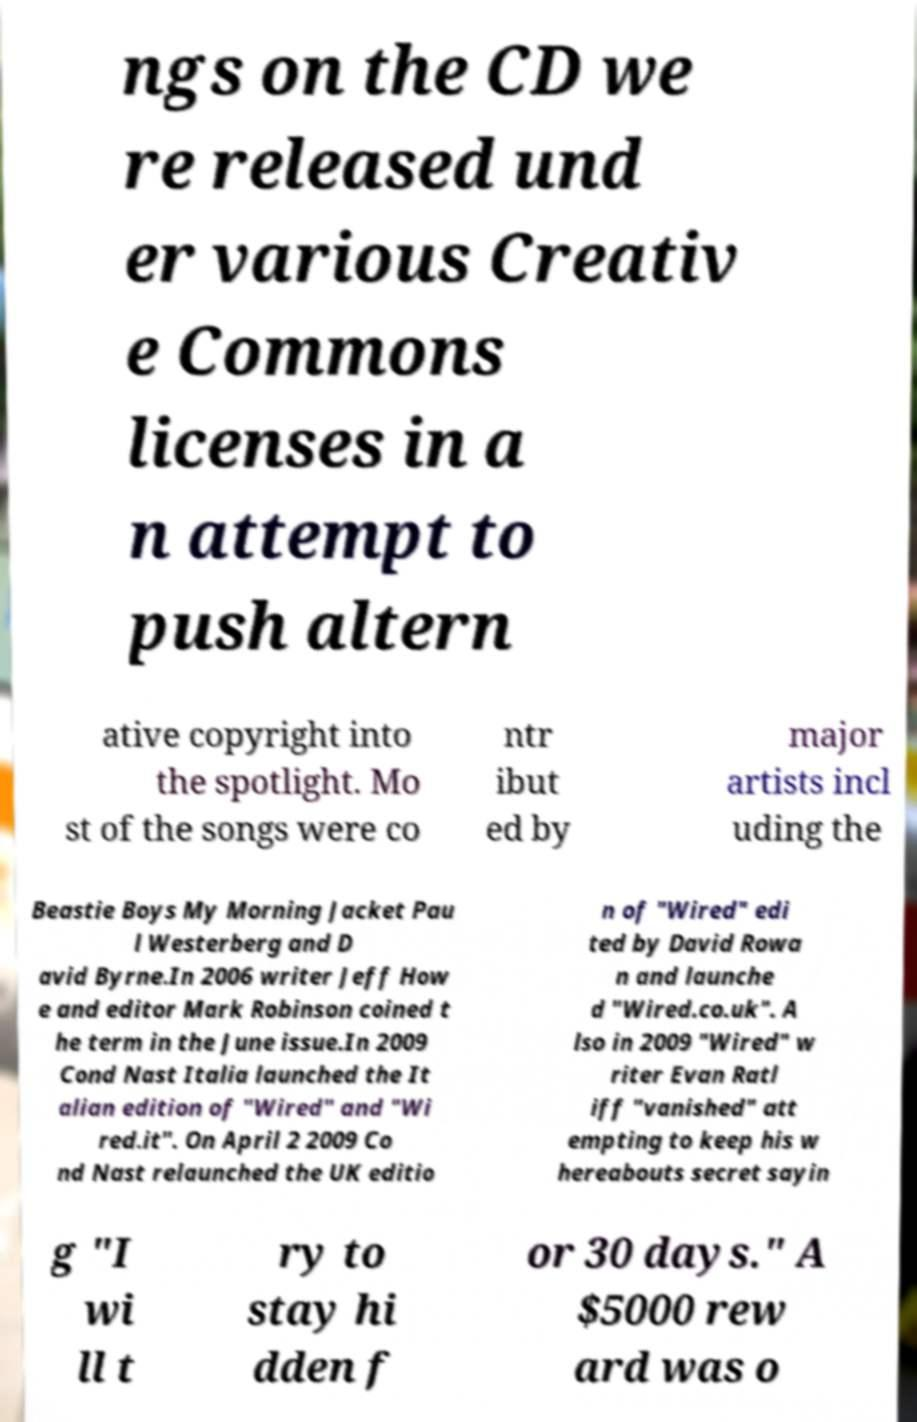For documentation purposes, I need the text within this image transcribed. Could you provide that? ngs on the CD we re released und er various Creativ e Commons licenses in a n attempt to push altern ative copyright into the spotlight. Mo st of the songs were co ntr ibut ed by major artists incl uding the Beastie Boys My Morning Jacket Pau l Westerberg and D avid Byrne.In 2006 writer Jeff How e and editor Mark Robinson coined t he term in the June issue.In 2009 Cond Nast Italia launched the It alian edition of "Wired" and "Wi red.it". On April 2 2009 Co nd Nast relaunched the UK editio n of "Wired" edi ted by David Rowa n and launche d "Wired.co.uk". A lso in 2009 "Wired" w riter Evan Ratl iff "vanished" att empting to keep his w hereabouts secret sayin g "I wi ll t ry to stay hi dden f or 30 days." A $5000 rew ard was o 